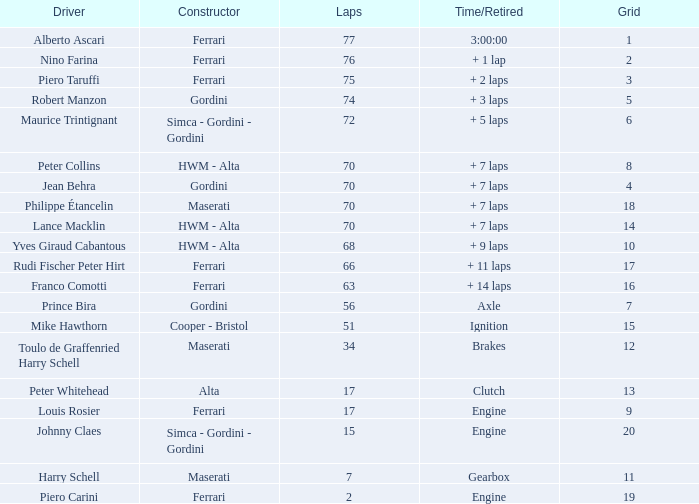Who maneuvered the car for beyond 66 laps within a 5-grid? Robert Manzon. 